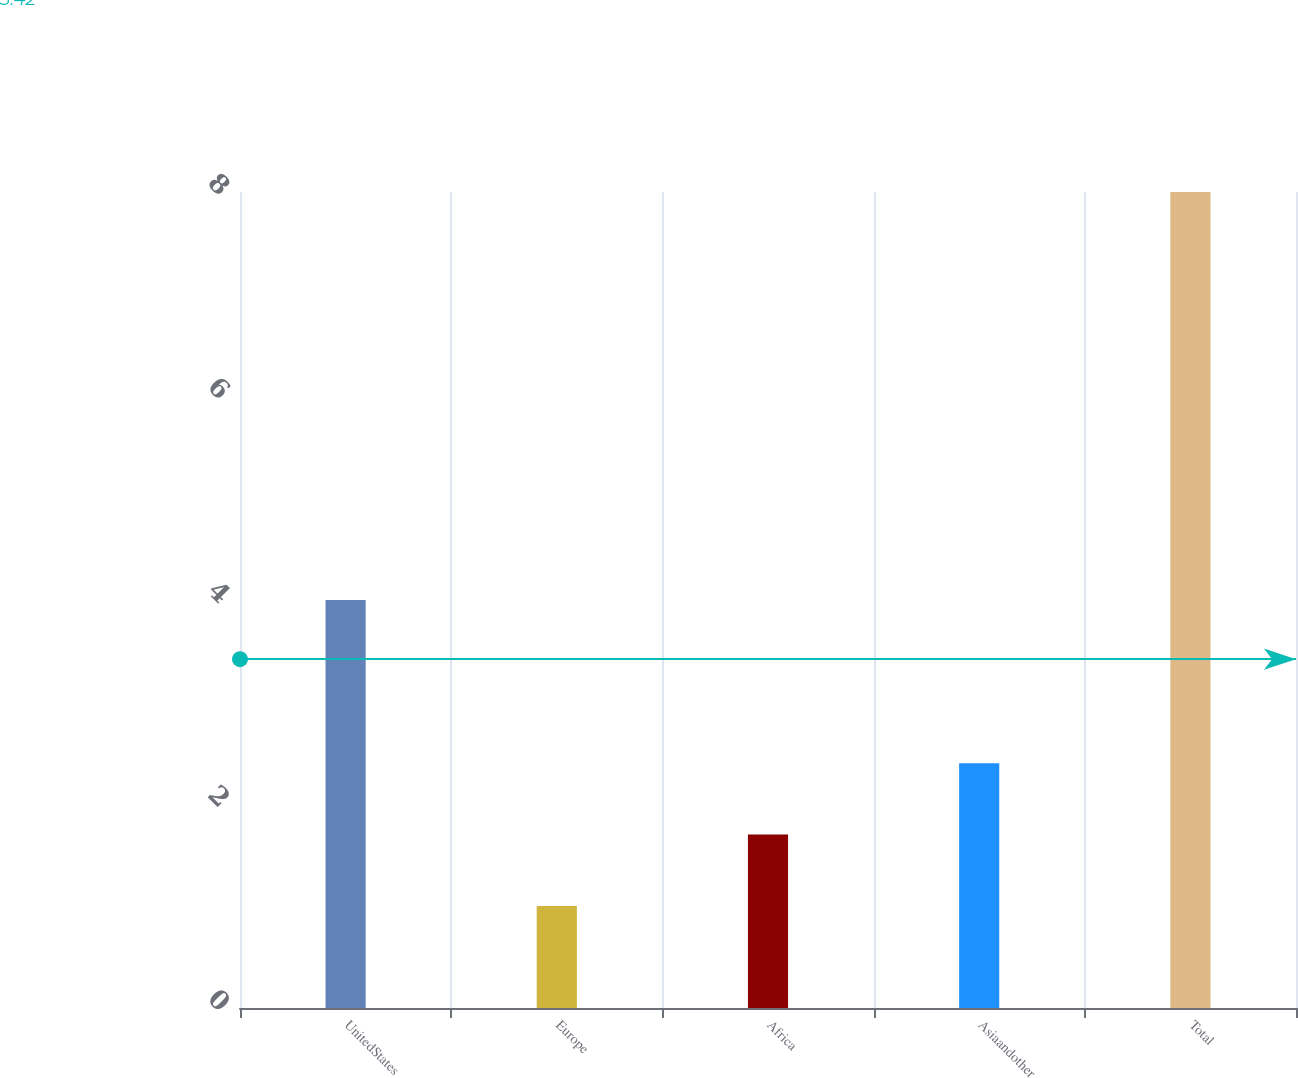Convert chart. <chart><loc_0><loc_0><loc_500><loc_500><bar_chart><fcel>UnitedStates<fcel>Europe<fcel>Africa<fcel>Asiaandother<fcel>Total<nl><fcel>4<fcel>1<fcel>1.7<fcel>2.4<fcel>8<nl></chart> 